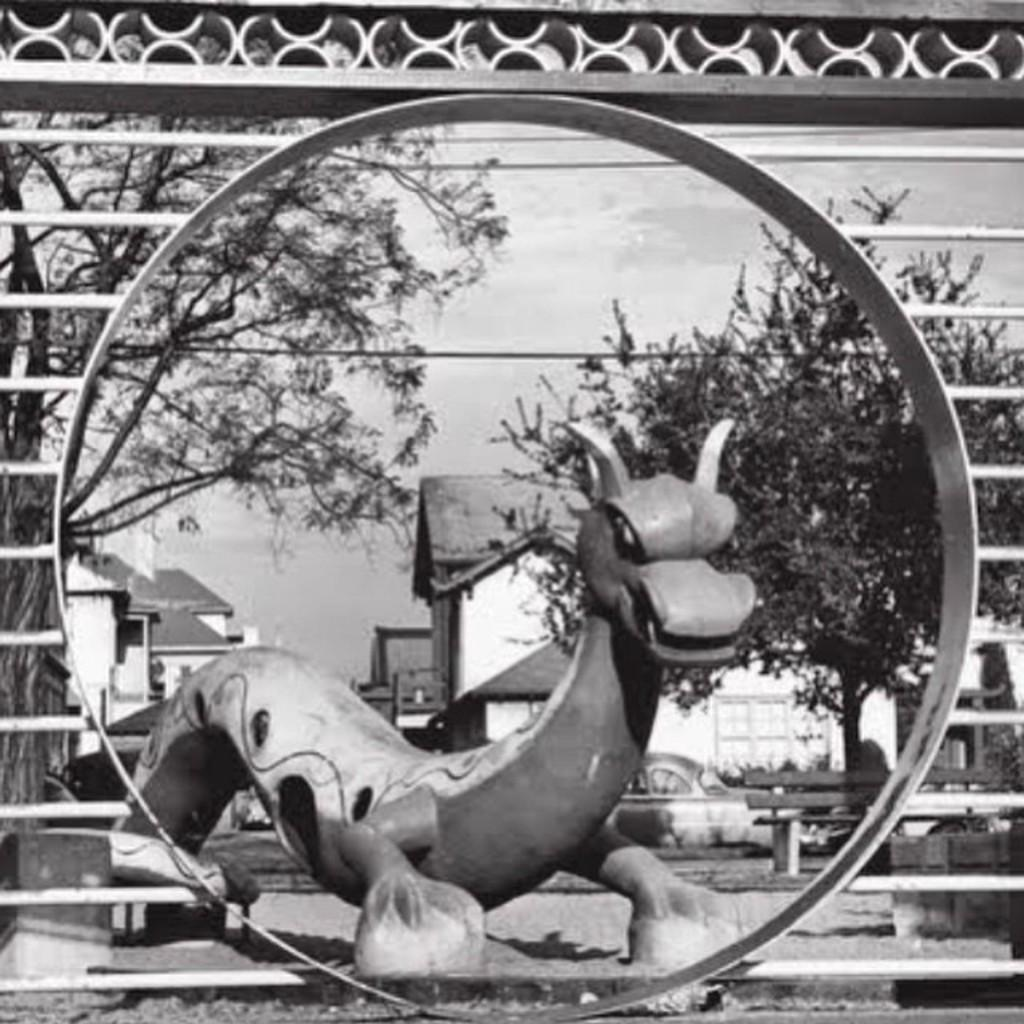What is the color scheme of the image? The image is black and white. What is the main subject of the image? There is a statue of a dragon in the image. What can be seen in the background of the image? There are trees and houses in the background of the image. What activity is the dragon participating in with the houses in the image? There is no activity involving the dragon and the houses in the image, as the image is static and does not depict any action. 